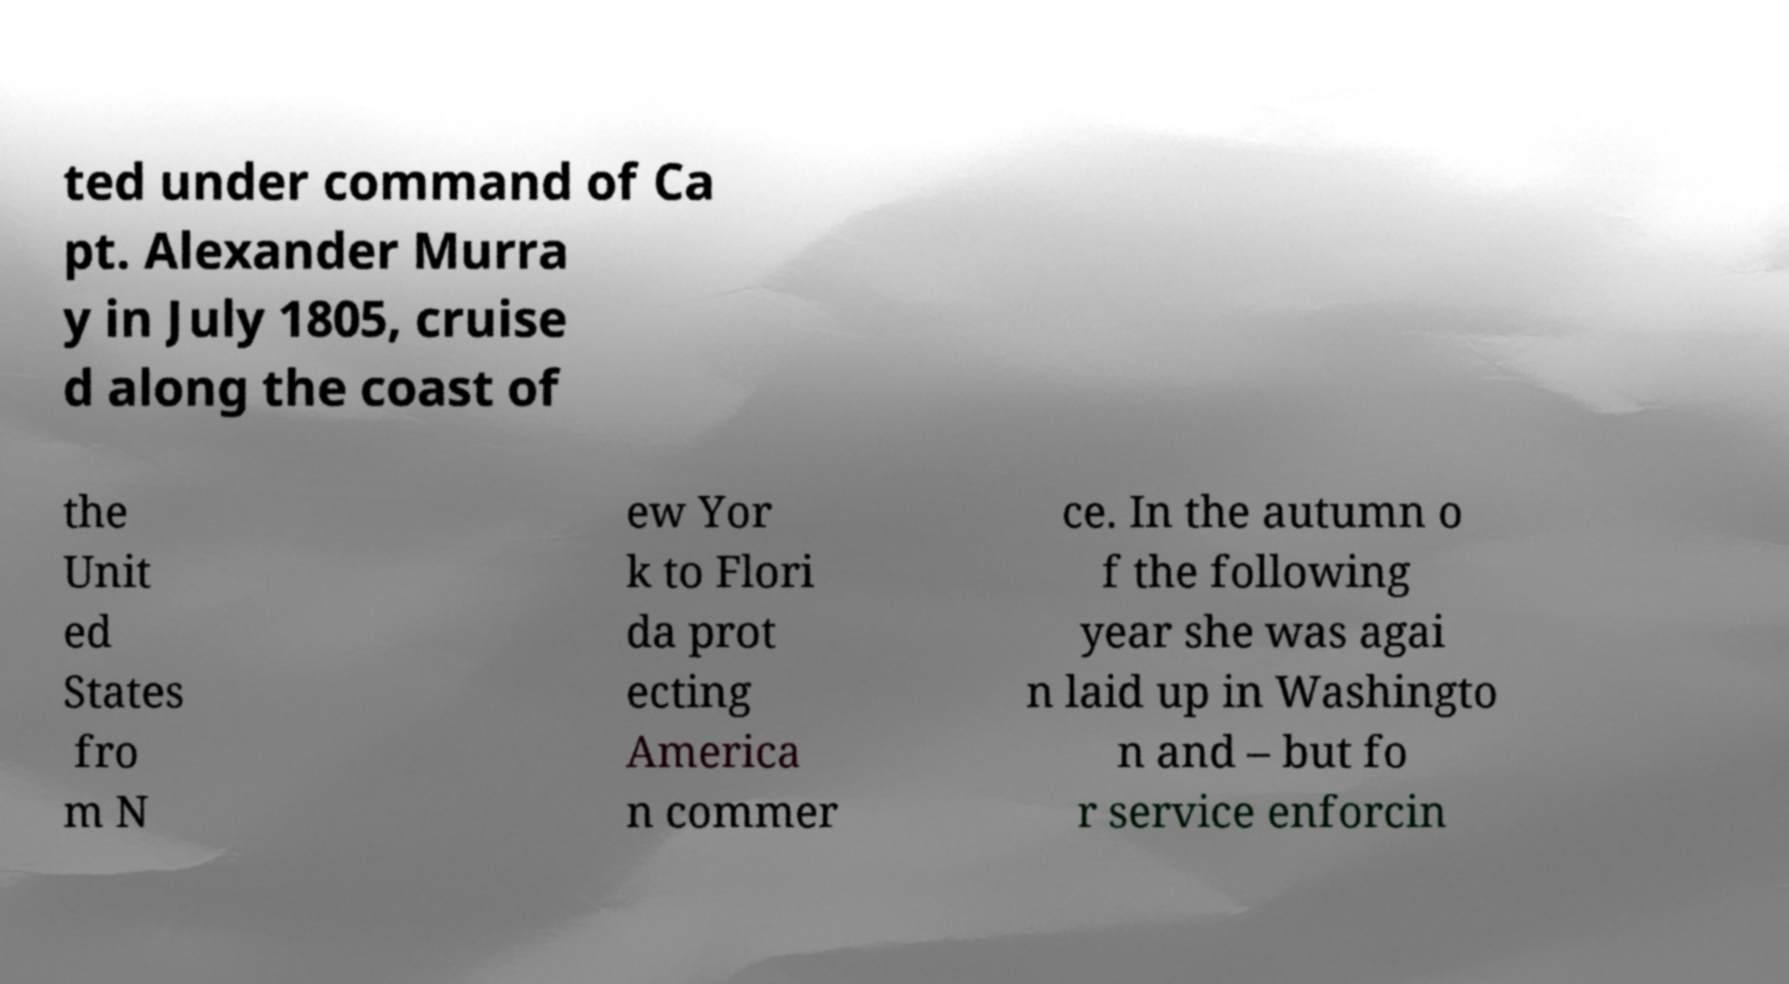There's text embedded in this image that I need extracted. Can you transcribe it verbatim? ted under command of Ca pt. Alexander Murra y in July 1805, cruise d along the coast of the Unit ed States fro m N ew Yor k to Flori da prot ecting America n commer ce. In the autumn o f the following year she was agai n laid up in Washingto n and – but fo r service enforcin 